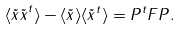<formula> <loc_0><loc_0><loc_500><loc_500>\langle { \tilde { x } \tilde { x } } ^ { t } \rangle - \langle { \tilde { x } } \rangle \langle { \tilde { x } } ^ { t } \rangle = { P } ^ { t } { F } { P } .</formula> 